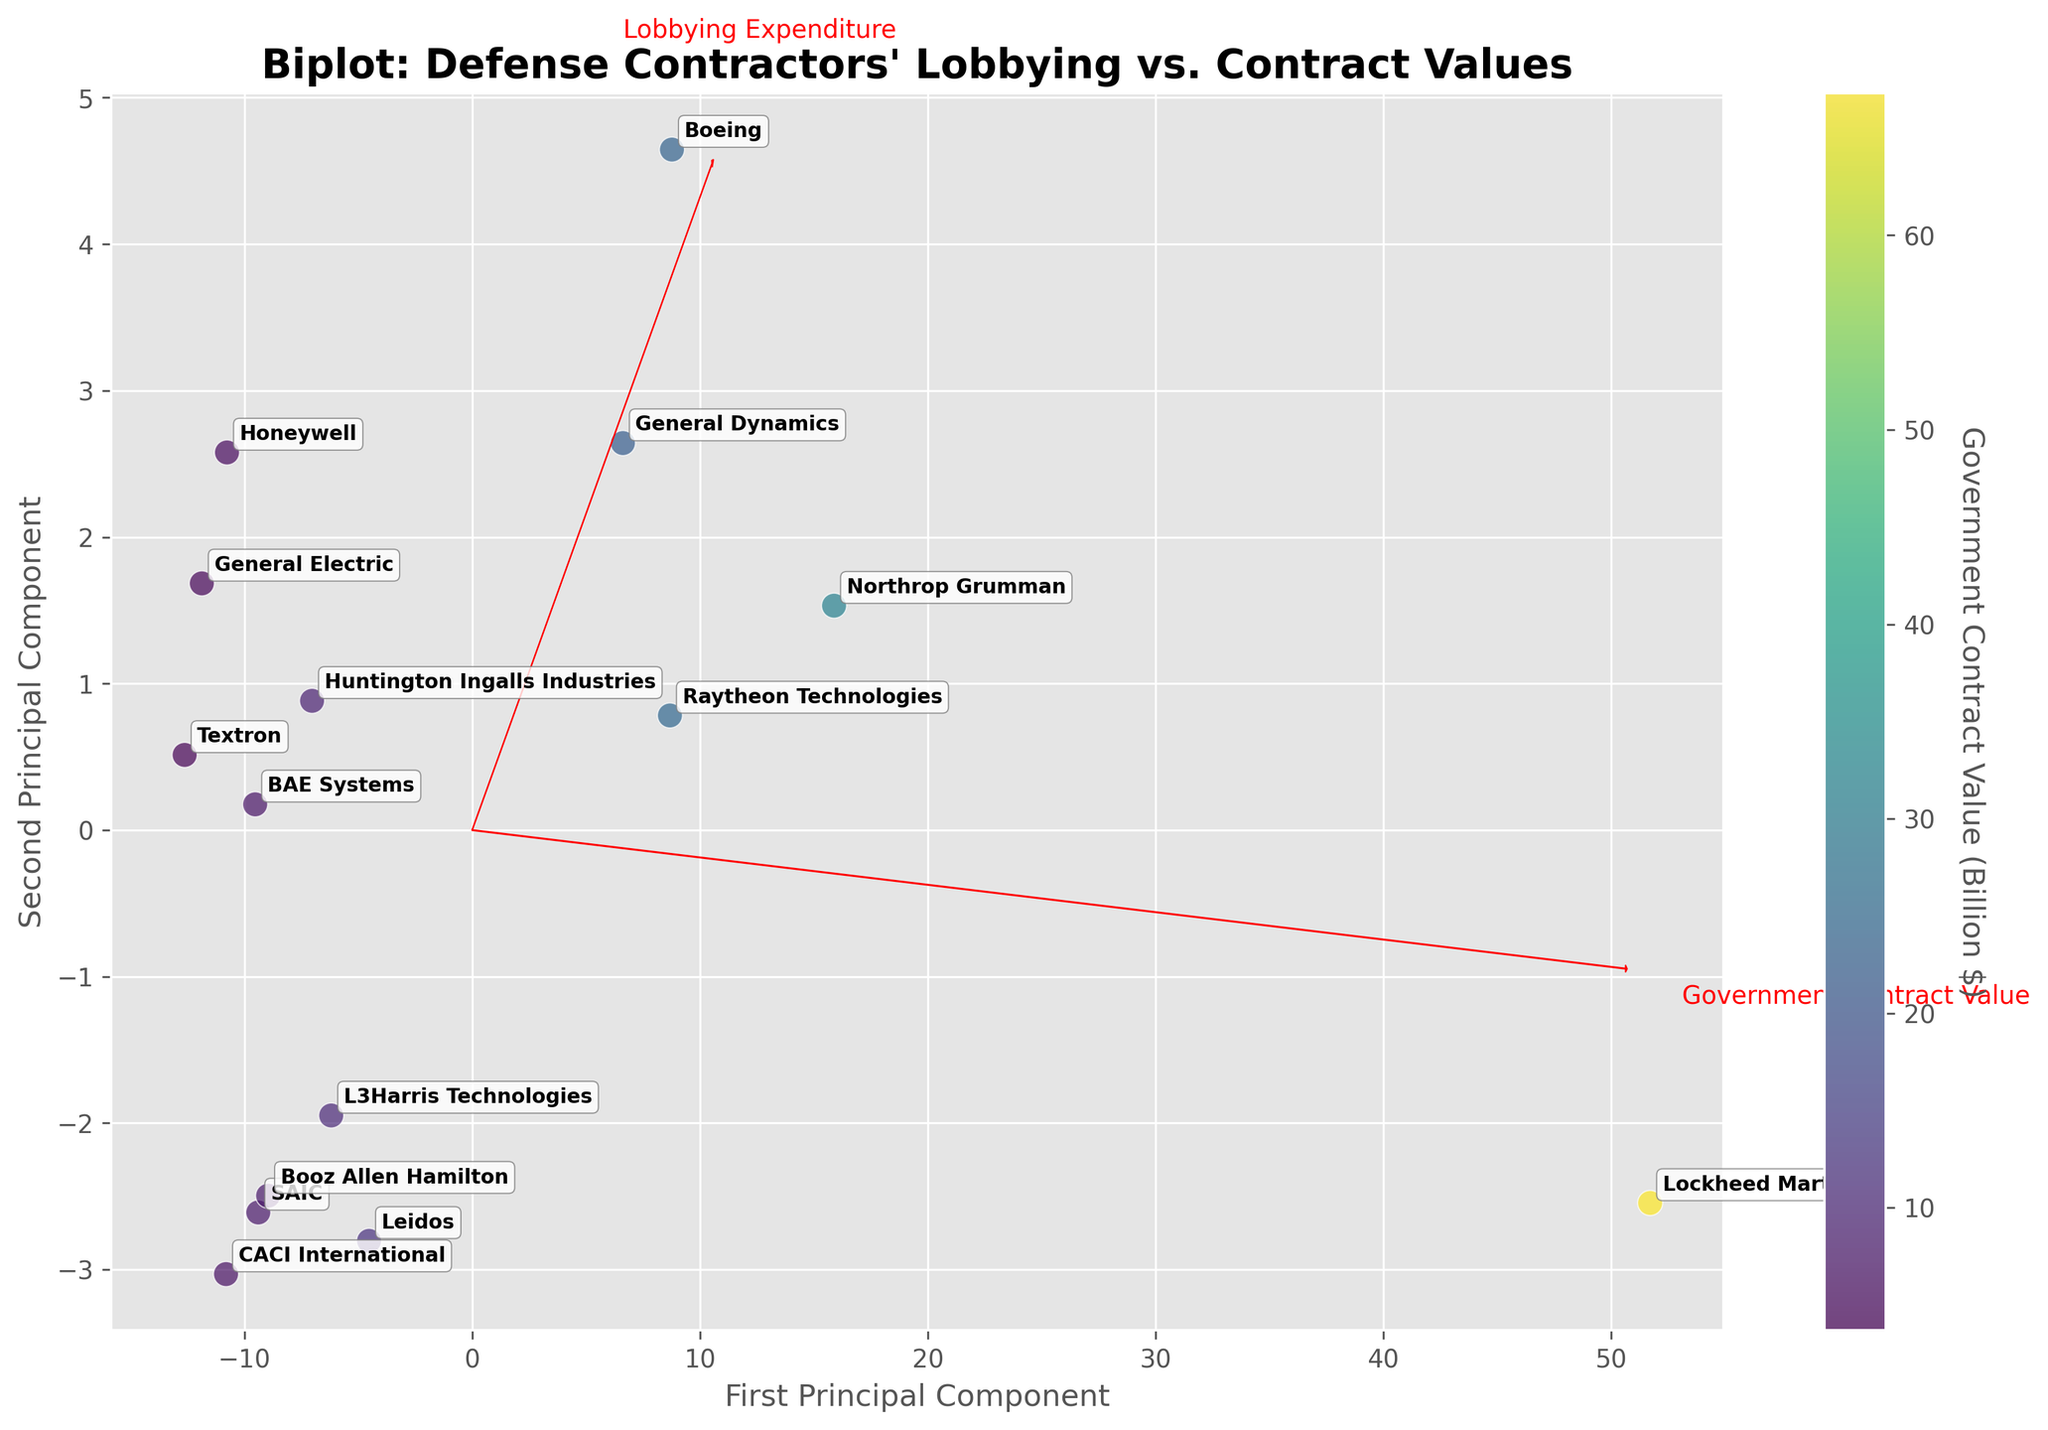How many companies are represented in the figure? Count the number of unique data points labeled in the figure. Each point represents a different company.
Answer: 15 Which company has the highest government contract value according to the color scale? Look at the color gradient in the scatter plot. The company with the darkest color is associated with the highest government contract value.
Answer: Lockheed Martin Which axis represents the "First Principal Component"? Identify the axis labeled "First Principal Component".
Answer: The x-axis Which companies have similar lobbying expenditures but different government contract values based on their position? Look for companies that are positioned close to each other along the axis representing lobbying expenditures (red arrow for x-access direction) but have notably different positions along the axis representing government contract values. For example, BAE Systems and Textron.
Answer: BAE Systems and Textron What is the title of the biplot? Read the large, bolded text at the top of the figure.
Answer: Biplot: Defense Contractors' Lobbying vs. Contract Values Which company is closest to the origin of the principal components? Look at the data points' positions and identify the one nearest to the origin (0,0).
Answer: CACI International Which two attributes are visualized with the eigenvectors in the biplot? Identify the directions of the red arrows and the labels attached to them in the figure.
Answer: Lobbying Expenditure and Government Contract Value How does the depiction of larger government contract values relate to the plotted positions of the companies along the principal components? Examine the color of the points and their relative position in the biplot; darker colors indicate higher government contract values.
Answer: Companies with larger government contract values tend to be positioned further along the positive direction of the first principal component 